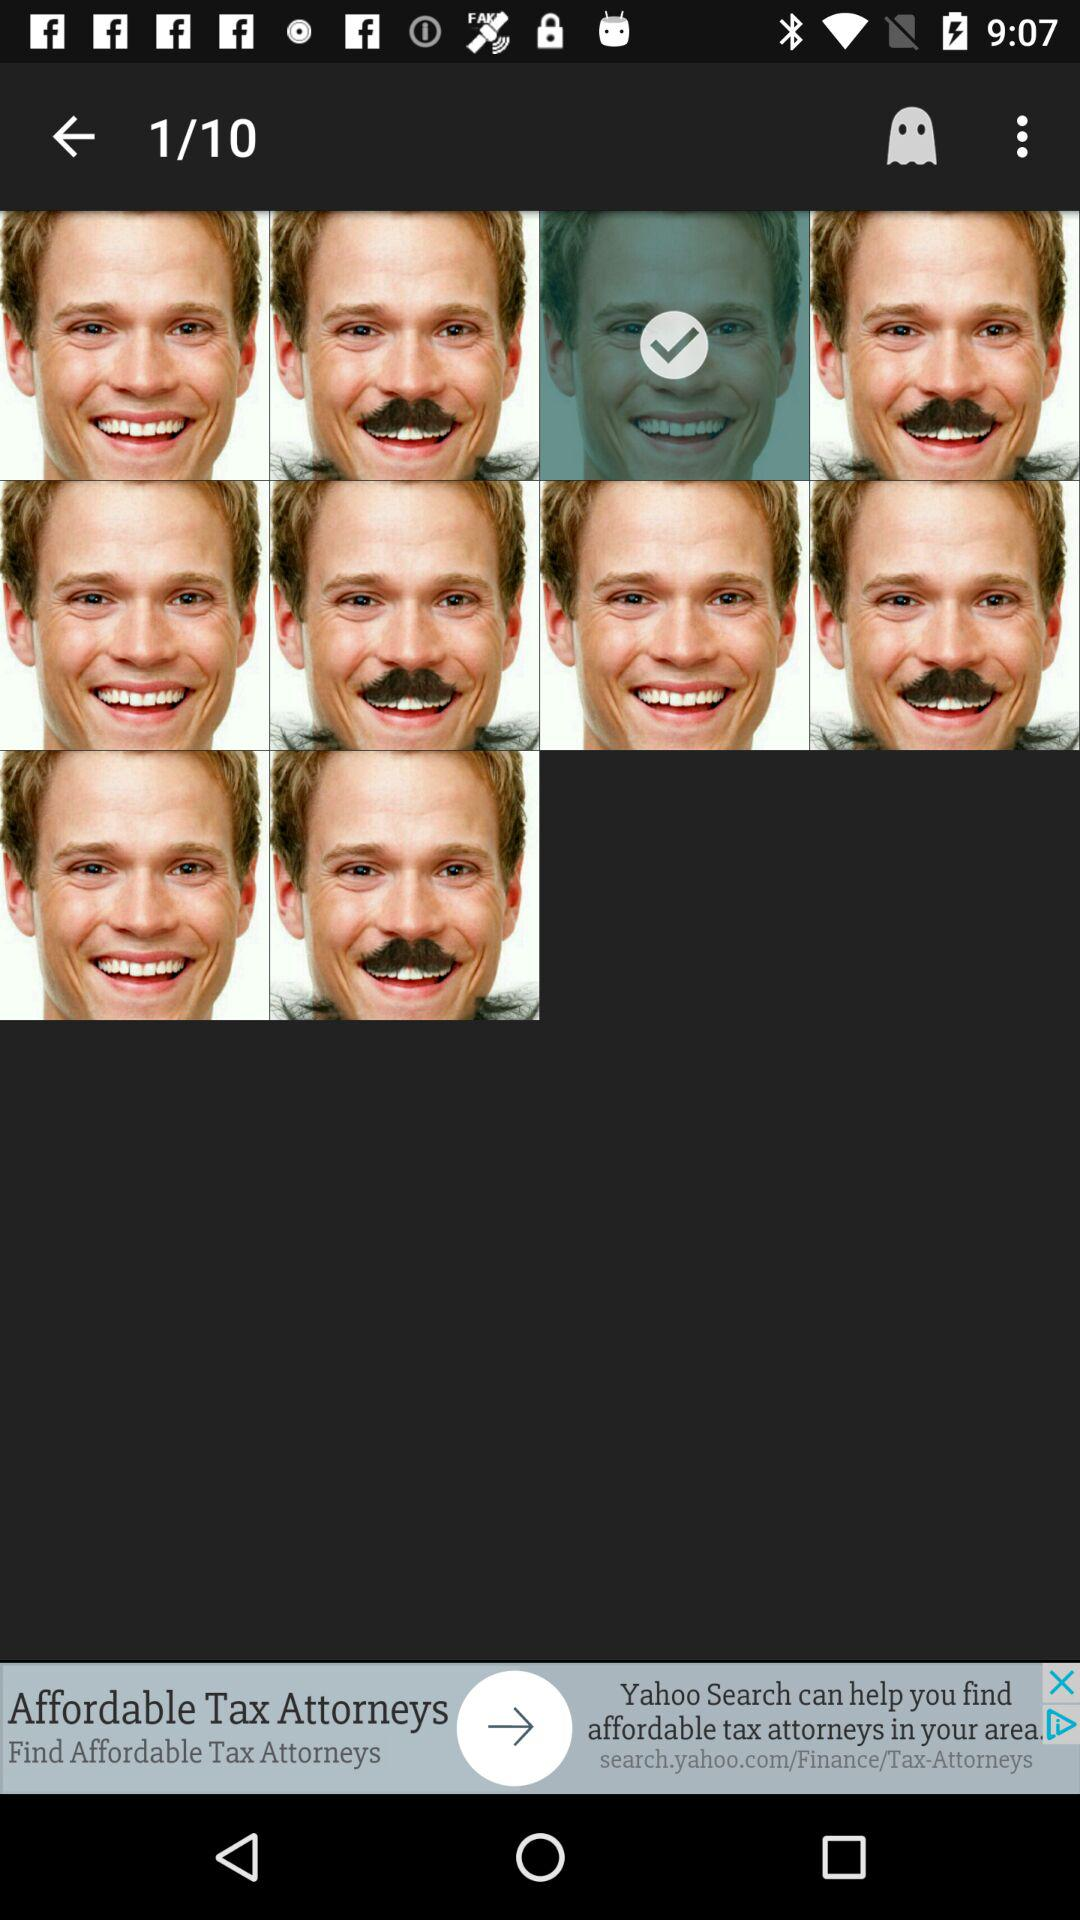How many total images are there? There are 10 total images. 